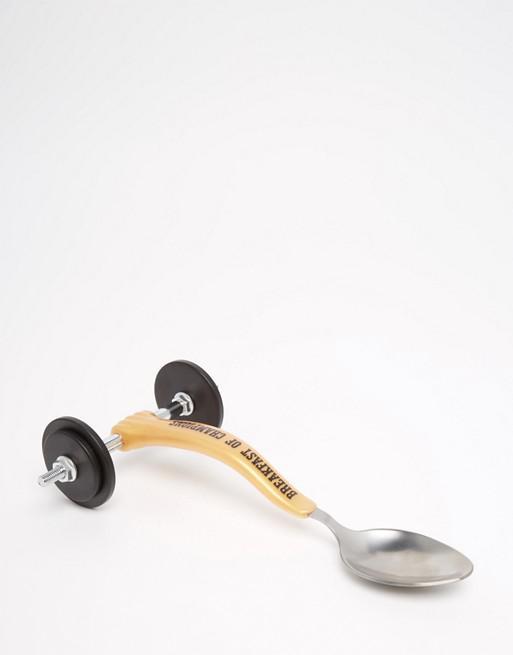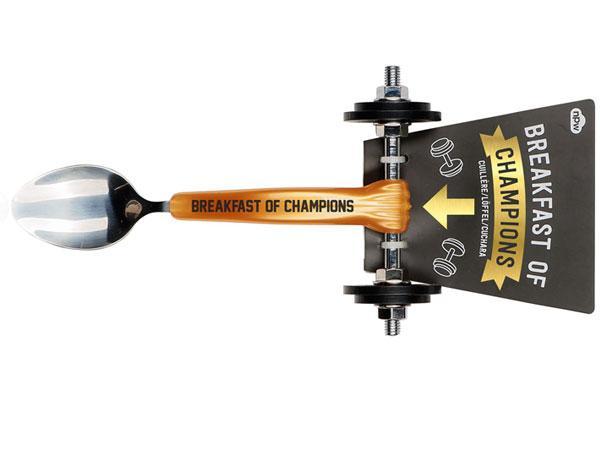The first image is the image on the left, the second image is the image on the right. For the images shown, is this caption "The spoon is turned toward the bottom left in one of the images." true? Answer yes or no. No. 